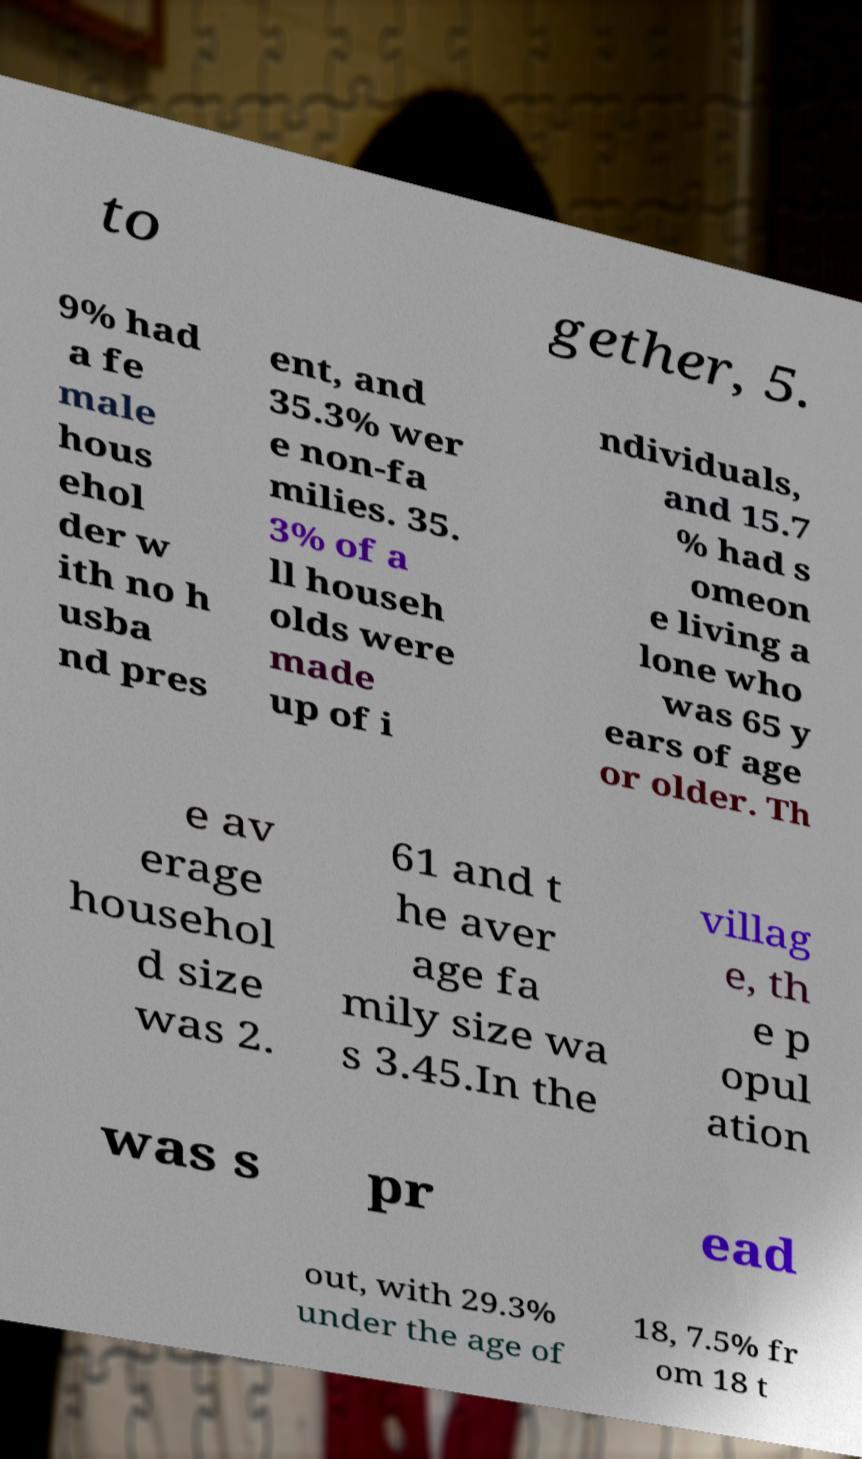Can you accurately transcribe the text from the provided image for me? to gether, 5. 9% had a fe male hous ehol der w ith no h usba nd pres ent, and 35.3% wer e non-fa milies. 35. 3% of a ll househ olds were made up of i ndividuals, and 15.7 % had s omeon e living a lone who was 65 y ears of age or older. Th e av erage househol d size was 2. 61 and t he aver age fa mily size wa s 3.45.In the villag e, th e p opul ation was s pr ead out, with 29.3% under the age of 18, 7.5% fr om 18 t 